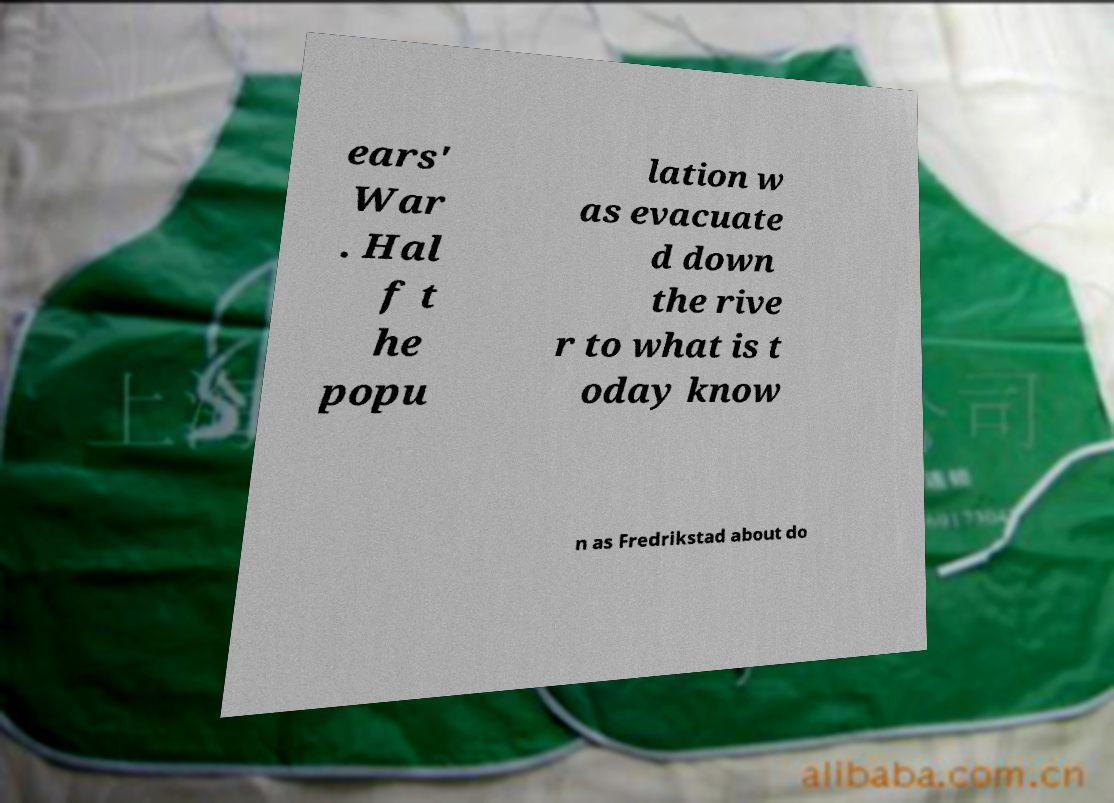Could you extract and type out the text from this image? ears' War . Hal f t he popu lation w as evacuate d down the rive r to what is t oday know n as Fredrikstad about do 